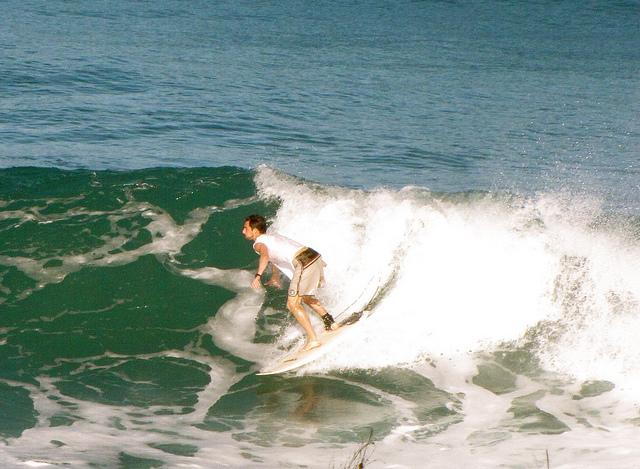Is she falling?
Quick response, please. No. What is this man doing?
Answer briefly. Surfing. Is there anything on the person's ankle?
Write a very short answer. Yes. 